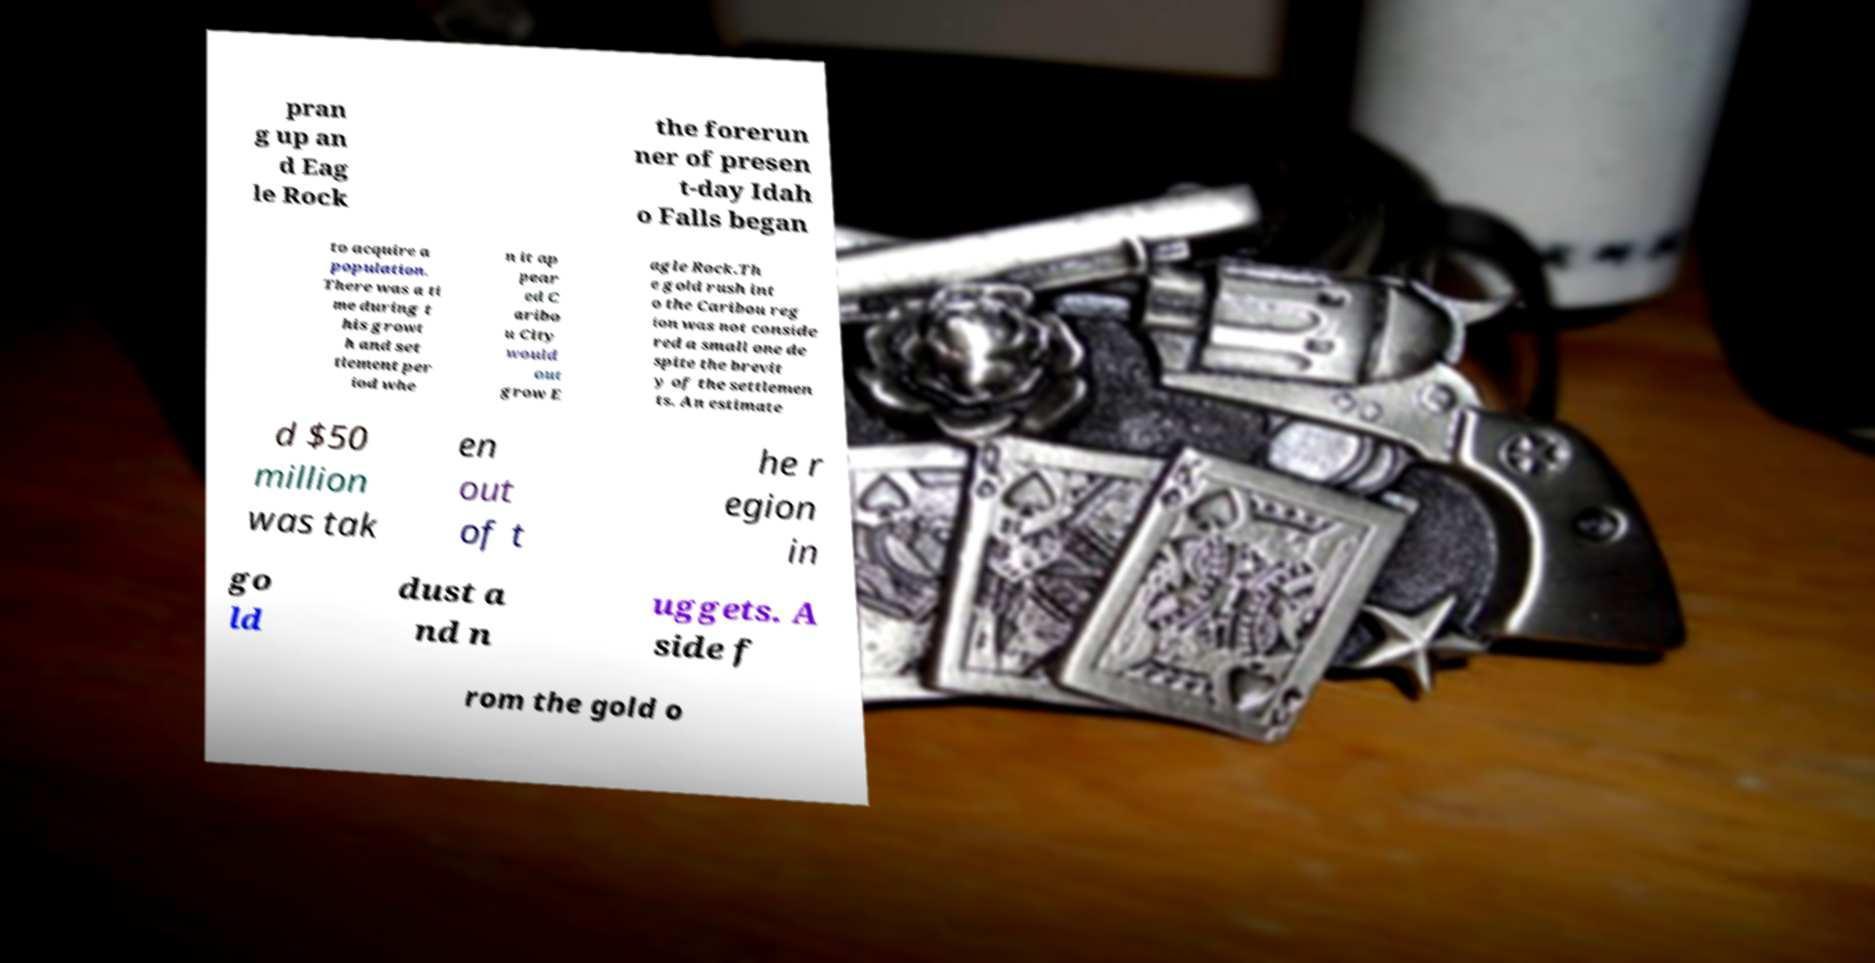Could you extract and type out the text from this image? pran g up an d Eag le Rock the forerun ner of presen t-day Idah o Falls began to acquire a population. There was a ti me during t his growt h and set tlement per iod whe n it ap pear ed C aribo u City would out grow E agle Rock.Th e gold rush int o the Caribou reg ion was not conside red a small one de spite the brevit y of the settlemen ts. An estimate d $50 million was tak en out of t he r egion in go ld dust a nd n uggets. A side f rom the gold o 